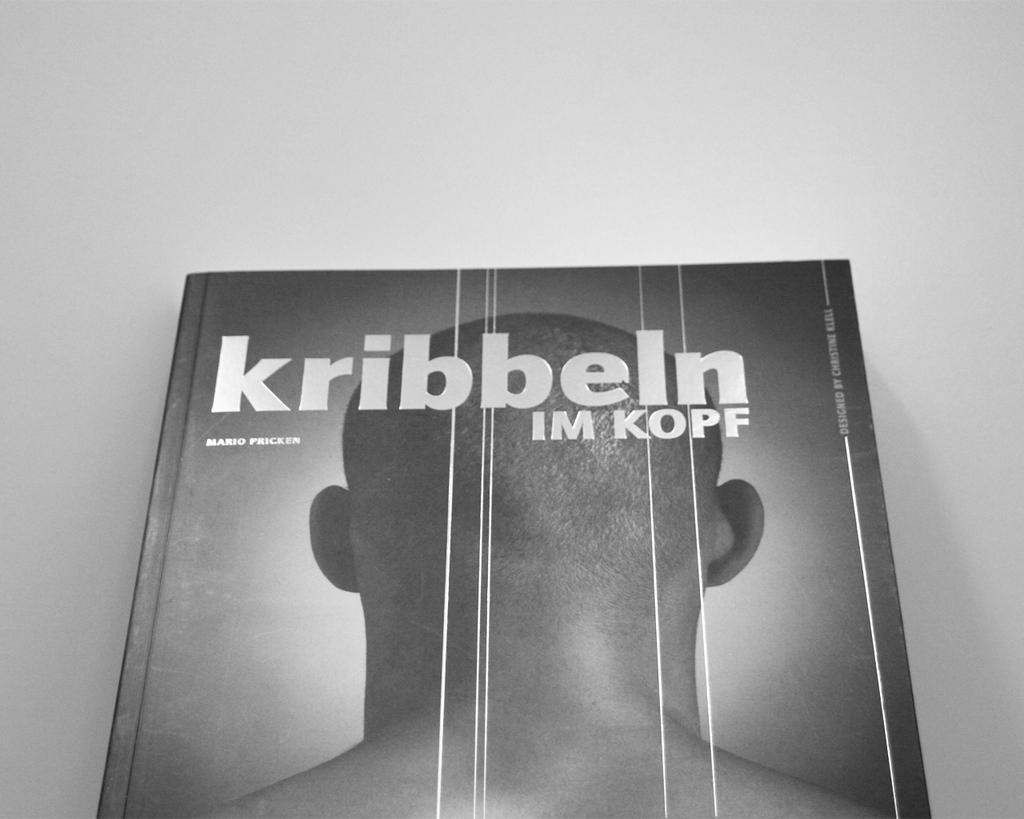Can you describe this image briefly? This is a black and white image. In this image we can see a book. 